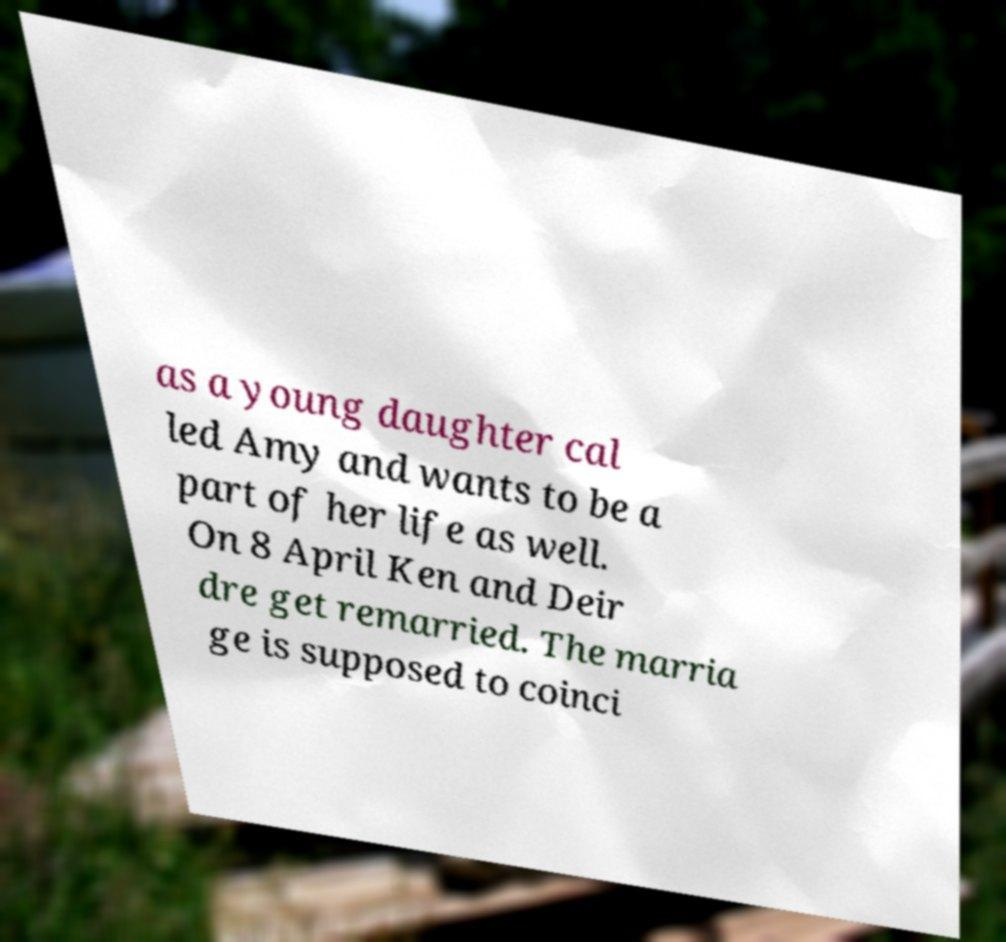Could you assist in decoding the text presented in this image and type it out clearly? as a young daughter cal led Amy and wants to be a part of her life as well. On 8 April Ken and Deir dre get remarried. The marria ge is supposed to coinci 